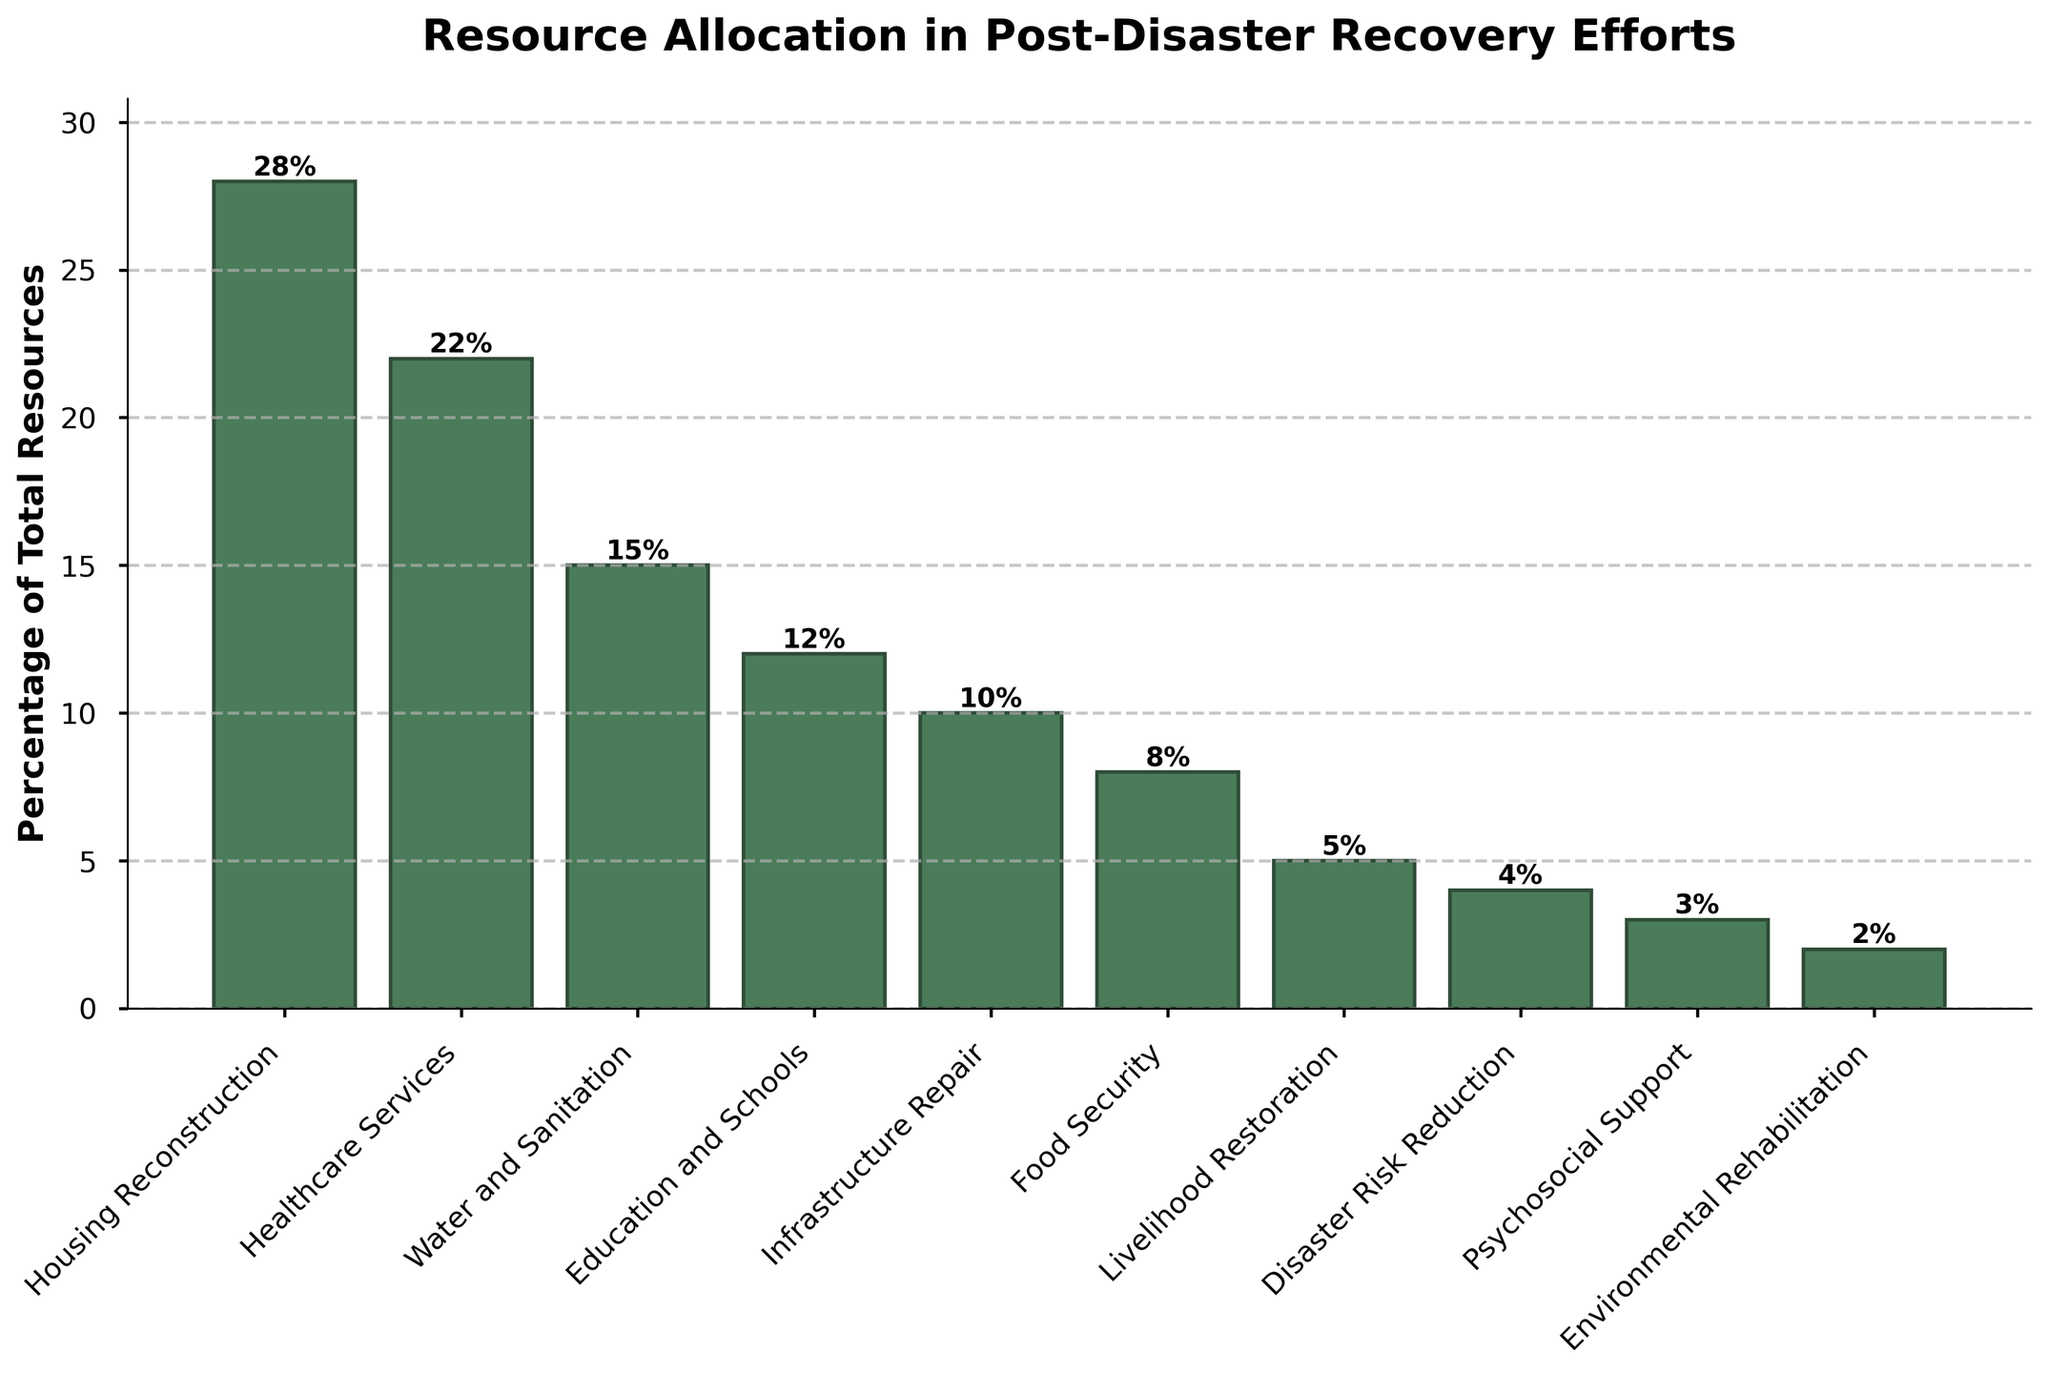What percentage of resources is allocated to Healthcare Services compared to Housing Reconstruction? Healthcare Services receive 22% of the resources, while Housing Reconstruction gets 28%. To compare them, we calculate their difference: 28% - 22% = 6%. This means Housing Reconstruction receives 6% more resources than Healthcare Services.
Answer: 6% Which sector receives the least amount of resources, and what percentage is it? Looking at the heights of the bars, Environmental Rehabilitation has the shortest bar, indicating it receives the least amount of resources. The label shows it receives 2% of the total resources.
Answer: Environmental Rehabilitation, 2% What is the total percentage of resources allocated to Education and Schools, Infrastructure Repair, and Food Security combined? Summing up the percentages for these sectors: Education and Schools (12%) + Infrastructure Repair (10%) + Food Security (8%) = 30%.
Answer: 30% Is there any sector that receives equal or less than 5% of the total resources? Observing the bars, Livelihood Restoration, Disaster Risk Reduction, Psychosocial Support, and Environmental Rehabilitation are ≤ 5%. Their respective percentages are Livelihood Restoration (5%), Disaster Risk Reduction (4%), Psychosocial Support (3%), and Environmental Rehabilitation (2%).
Answer: Yes, four sectors: Livelihood Restoration (5%), Disaster Risk Reduction (4%), Psychosocial Support (3%), Environmental Rehabilitation (2%) What is the combined percentage of resources allocated to Housing Reconstruction and Healthcare Services? The percentages for Housing Reconstruction and Healthcare Services are 28% and 22%, respectively. Adding them up gives: 28% + 22% = 50%.
Answer: 50% Does Water and Sanitation receive more resources than Food Security and Livelihood Restoration combined? Water and Sanitation receives 15%. Summing up the percentages for Food Security (8%) and Livelihood Restoration (5%) gives 13%. Since 15% > 13%, Water and Sanitation receives more resources.
Answer: Yes Which three sectors receive the highest allocation of resources, and what are their corresponding percentages? The three tallest bars represent the sectors with the highest allocations. They are Housing Reconstruction (28%), Healthcare Services (22%), and Water and Sanitation (15%).
Answer: Housing Reconstruction (28%), Healthcare Services (22%), Water and Sanitation (15%) What is the difference in resource allocation between Infrastructure Repair and Food Security? Subtracting the percentage of Food Security (8%) from Infrastructure Repair (10%) gives: 10% - 8% = 2%.
Answer: 2% Which sector receives the third-lowest allocation of resources, and what percentage is it? Analyzing the bars from shortest to tallest, the third shortest is Psychosocial Support, which receives 3% of the total resources.
Answer: Psychosocial Support, 3% How much more percentage do Housing Reconstruction and Healthcare Services combined receive compared to Water and Sanitation? Housing Reconstruction (28%) + Healthcare Services (22%) = 50%. Water and Sanitation receives 15%. The difference is 50% - 15% = 35%.
Answer: 35% 